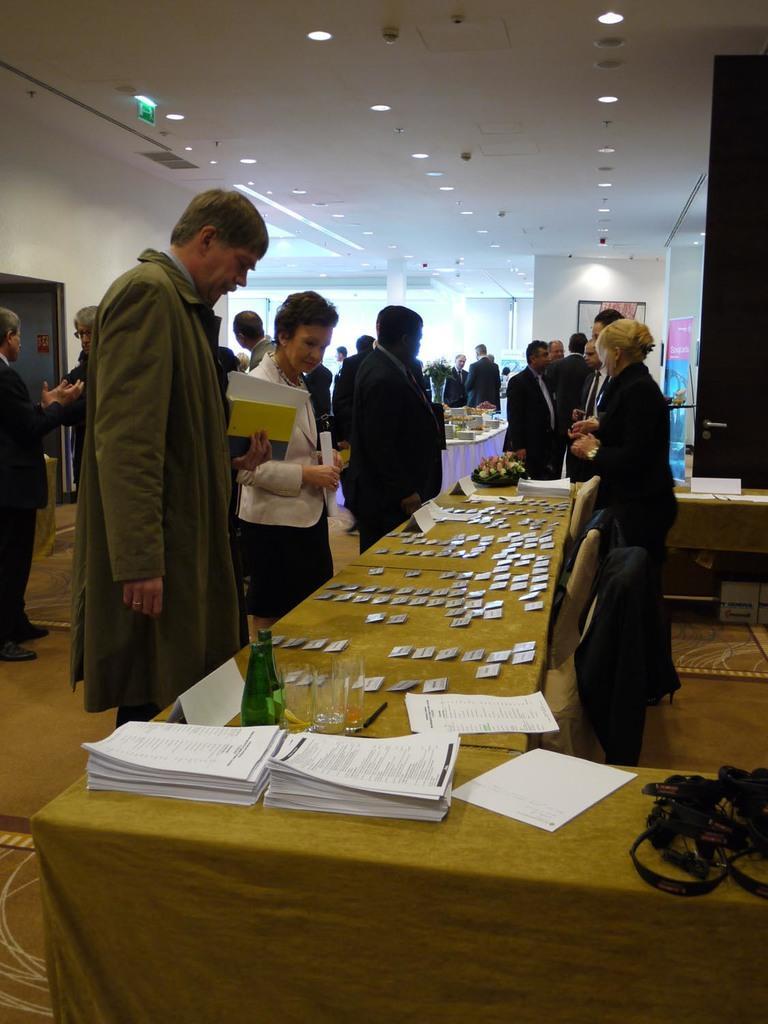How would you summarize this image in a sentence or two? As we can see in the image there are few people standing over here, white color wall and a table. On table there is a bottle and papers. 